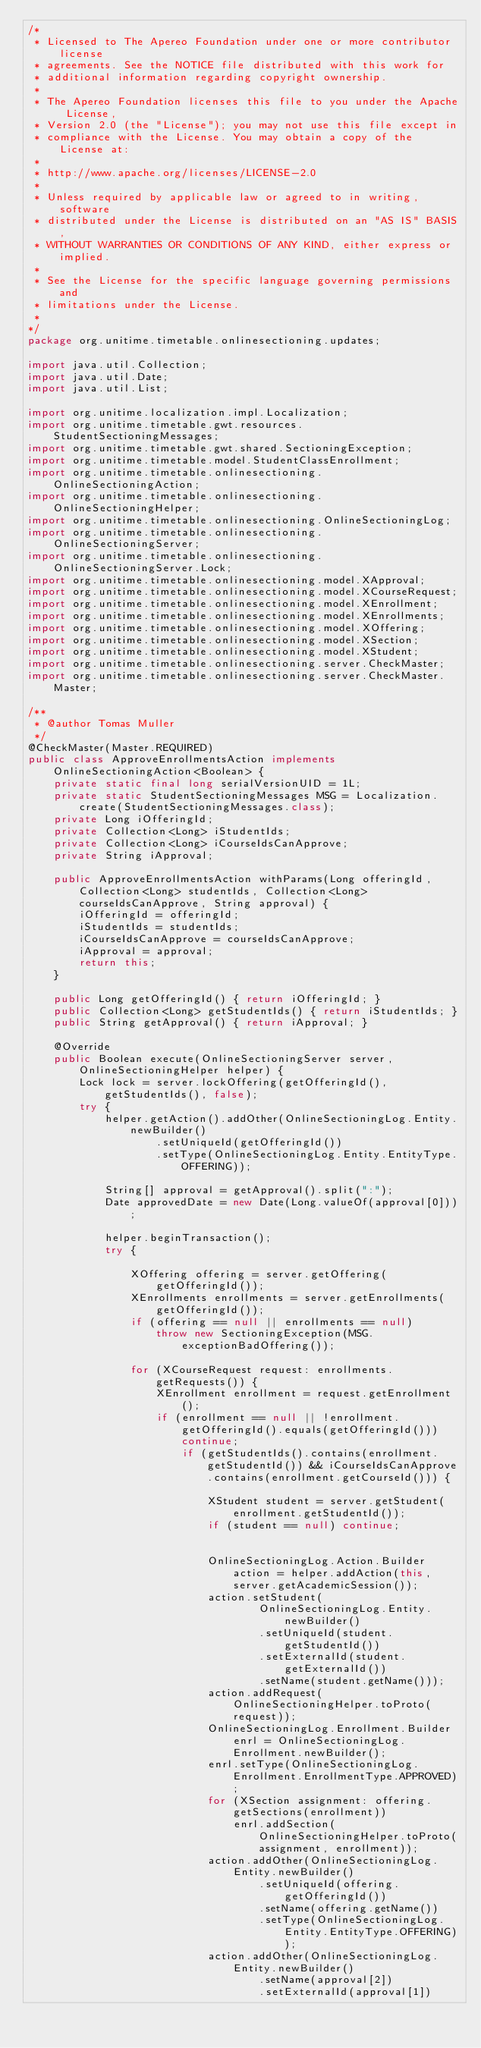<code> <loc_0><loc_0><loc_500><loc_500><_Java_>/*
 * Licensed to The Apereo Foundation under one or more contributor license
 * agreements. See the NOTICE file distributed with this work for
 * additional information regarding copyright ownership.
 *
 * The Apereo Foundation licenses this file to you under the Apache License,
 * Version 2.0 (the "License"); you may not use this file except in
 * compliance with the License. You may obtain a copy of the License at:
 *
 * http://www.apache.org/licenses/LICENSE-2.0
 *
 * Unless required by applicable law or agreed to in writing, software
 * distributed under the License is distributed on an "AS IS" BASIS,
 * WITHOUT WARRANTIES OR CONDITIONS OF ANY KIND, either express or implied.
 *
 * See the License for the specific language governing permissions and
 * limitations under the License.
 * 
*/
package org.unitime.timetable.onlinesectioning.updates;

import java.util.Collection;
import java.util.Date;
import java.util.List;

import org.unitime.localization.impl.Localization;
import org.unitime.timetable.gwt.resources.StudentSectioningMessages;
import org.unitime.timetable.gwt.shared.SectioningException;
import org.unitime.timetable.model.StudentClassEnrollment;
import org.unitime.timetable.onlinesectioning.OnlineSectioningAction;
import org.unitime.timetable.onlinesectioning.OnlineSectioningHelper;
import org.unitime.timetable.onlinesectioning.OnlineSectioningLog;
import org.unitime.timetable.onlinesectioning.OnlineSectioningServer;
import org.unitime.timetable.onlinesectioning.OnlineSectioningServer.Lock;
import org.unitime.timetable.onlinesectioning.model.XApproval;
import org.unitime.timetable.onlinesectioning.model.XCourseRequest;
import org.unitime.timetable.onlinesectioning.model.XEnrollment;
import org.unitime.timetable.onlinesectioning.model.XEnrollments;
import org.unitime.timetable.onlinesectioning.model.XOffering;
import org.unitime.timetable.onlinesectioning.model.XSection;
import org.unitime.timetable.onlinesectioning.model.XStudent;
import org.unitime.timetable.onlinesectioning.server.CheckMaster;
import org.unitime.timetable.onlinesectioning.server.CheckMaster.Master;

/**
 * @author Tomas Muller
 */
@CheckMaster(Master.REQUIRED)
public class ApproveEnrollmentsAction implements OnlineSectioningAction<Boolean> {
	private static final long serialVersionUID = 1L;
	private static StudentSectioningMessages MSG = Localization.create(StudentSectioningMessages.class);
	private Long iOfferingId;
	private Collection<Long> iStudentIds;
	private Collection<Long> iCourseIdsCanApprove;
	private String iApproval;
	
	public ApproveEnrollmentsAction withParams(Long offeringId, Collection<Long> studentIds, Collection<Long> courseIdsCanApprove, String approval) {
		iOfferingId = offeringId;
		iStudentIds = studentIds;
		iCourseIdsCanApprove = courseIdsCanApprove;
		iApproval = approval;
		return this;
	}
	
	public Long getOfferingId() { return iOfferingId; }
	public Collection<Long> getStudentIds() { return iStudentIds; }
	public String getApproval() { return iApproval; }

	@Override
	public Boolean execute(OnlineSectioningServer server, OnlineSectioningHelper helper) {
		Lock lock = server.lockOffering(getOfferingId(), getStudentIds(), false);
		try {
			helper.getAction().addOther(OnlineSectioningLog.Entity.newBuilder()
					.setUniqueId(getOfferingId())
					.setType(OnlineSectioningLog.Entity.EntityType.OFFERING));

			String[] approval = getApproval().split(":");
			Date approvedDate = new Date(Long.valueOf(approval[0]));

			helper.beginTransaction();
			try {
				
				XOffering offering = server.getOffering(getOfferingId());
				XEnrollments enrollments = server.getEnrollments(getOfferingId());
				if (offering == null || enrollments == null) 
					throw new SectioningException(MSG.exceptionBadOffering());
				
				for (XCourseRequest request: enrollments.getRequests()) {
					XEnrollment enrollment = request.getEnrollment();
					if (enrollment == null || !enrollment.getOfferingId().equals(getOfferingId())) continue;
						if (getStudentIds().contains(enrollment.getStudentId()) && iCourseIdsCanApprove.contains(enrollment.getCourseId())) {
							
							XStudent student = server.getStudent(enrollment.getStudentId());
							if (student == null) continue;
							
							
							OnlineSectioningLog.Action.Builder action = helper.addAction(this, server.getAcademicSession());
							action.setStudent(
									OnlineSectioningLog.Entity.newBuilder()
									.setUniqueId(student.getStudentId())
									.setExternalId(student.getExternalId())
									.setName(student.getName()));
							action.addRequest(OnlineSectioningHelper.toProto(request));
							OnlineSectioningLog.Enrollment.Builder enrl = OnlineSectioningLog.Enrollment.newBuilder();
							enrl.setType(OnlineSectioningLog.Enrollment.EnrollmentType.APPROVED);
							for (XSection assignment: offering.getSections(enrollment))
								enrl.addSection(OnlineSectioningHelper.toProto(assignment, enrollment));
							action.addOther(OnlineSectioningLog.Entity.newBuilder()
									.setUniqueId(offering.getOfferingId())
									.setName(offering.getName())
									.setType(OnlineSectioningLog.Entity.EntityType.OFFERING));
							action.addOther(OnlineSectioningLog.Entity.newBuilder()
									.setName(approval[2])
									.setExternalId(approval[1])</code> 